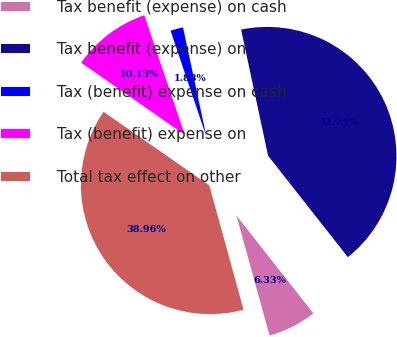Convert chart. <chart><loc_0><loc_0><loc_500><loc_500><pie_chart><fcel>Tax benefit (expense) on cash<fcel>Tax benefit (expense) on<fcel>Tax (benefit) expense on cash<fcel>Tax (benefit) expense on<fcel>Total tax effect on other<nl><fcel>6.33%<fcel>42.75%<fcel>1.83%<fcel>10.13%<fcel>38.96%<nl></chart> 